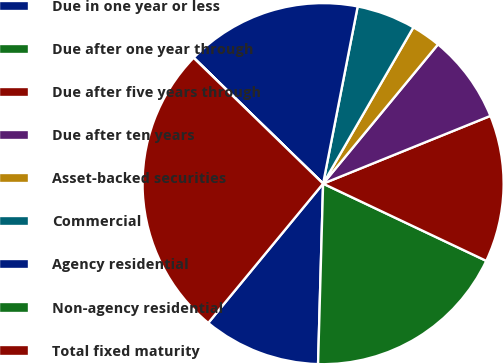Convert chart. <chart><loc_0><loc_0><loc_500><loc_500><pie_chart><fcel>Due in one year or less<fcel>Due after one year through<fcel>Due after five years through<fcel>Due after ten years<fcel>Asset-backed securities<fcel>Commercial<fcel>Agency residential<fcel>Non-agency residential<fcel>Total fixed maturity<nl><fcel>10.53%<fcel>18.41%<fcel>13.16%<fcel>7.9%<fcel>2.64%<fcel>5.27%<fcel>15.79%<fcel>0.01%<fcel>26.3%<nl></chart> 